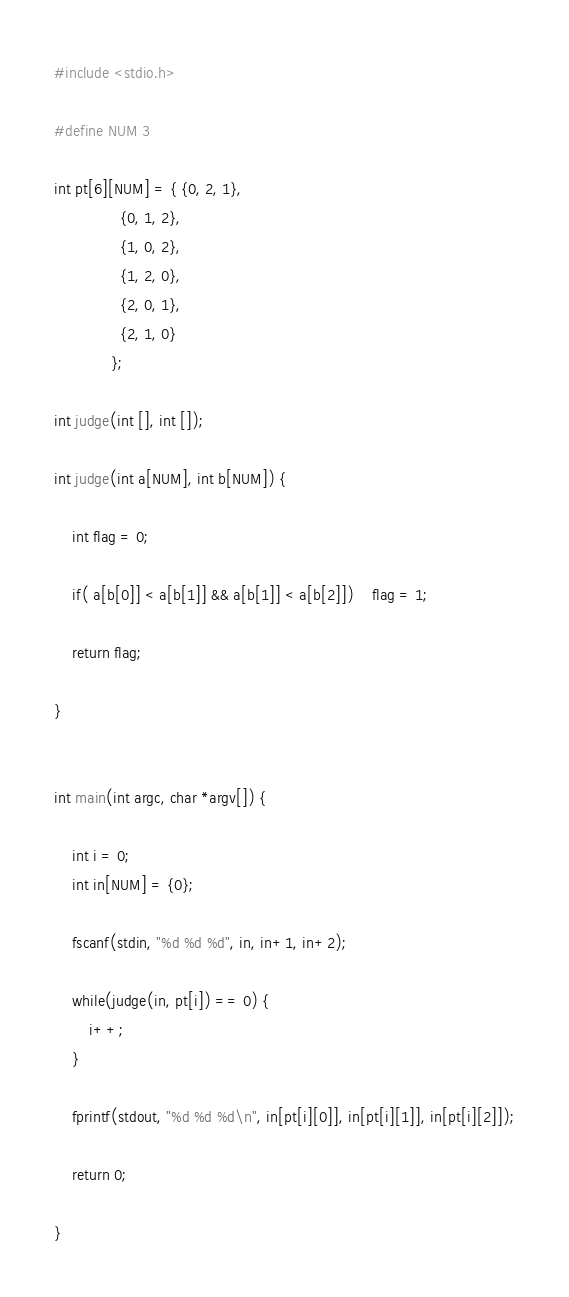<code> <loc_0><loc_0><loc_500><loc_500><_C_>#include <stdio.h>

#define NUM 3

int pt[6][NUM] = { {0, 2, 1},
			   {0, 1, 2},
			   {1, 0, 2},
			   {1, 2, 0},
			   {2, 0, 1},
			   {2, 1, 0}
			 };

int judge(int [], int []);

int judge(int a[NUM], int b[NUM]) {
	
	int flag = 0;
	
	if( a[b[0]] < a[b[1]] && a[b[1]] < a[b[2]])	flag = 1;
	
	return flag;
	
}


int main(int argc, char *argv[]) {
	
	int i = 0;
	int in[NUM] = {0};
	
	fscanf(stdin, "%d %d %d", in, in+1, in+2);
	
	while(judge(in, pt[i]) == 0) {
		i++;
	}
	
	fprintf(stdout, "%d %d %d\n", in[pt[i][0]], in[pt[i][1]], in[pt[i][2]]);
	
	return 0;

}</code> 